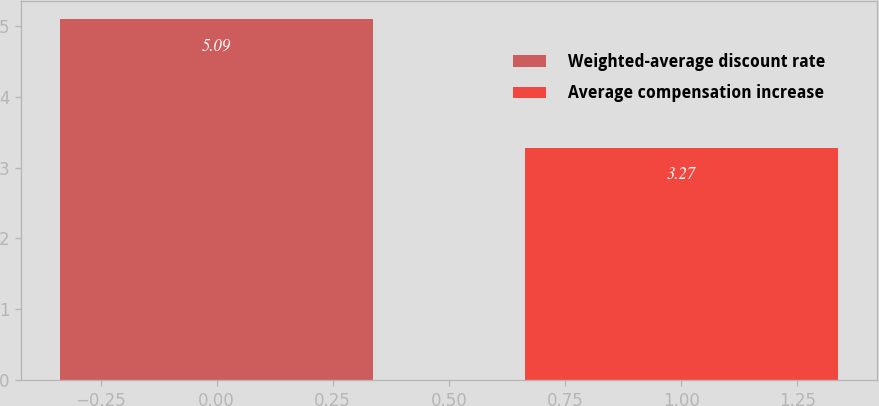Convert chart to OTSL. <chart><loc_0><loc_0><loc_500><loc_500><bar_chart><fcel>Weighted-average discount rate<fcel>Average compensation increase<nl><fcel>5.09<fcel>3.27<nl></chart> 